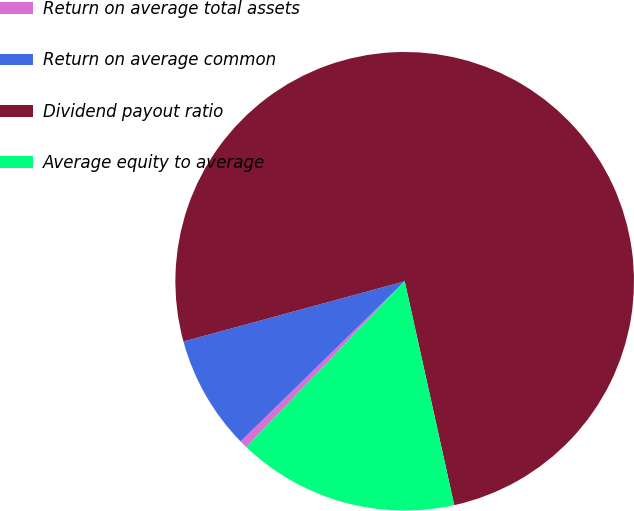Convert chart. <chart><loc_0><loc_0><loc_500><loc_500><pie_chart><fcel>Return on average total assets<fcel>Return on average common<fcel>Dividend payout ratio<fcel>Average equity to average<nl><fcel>0.56%<fcel>8.08%<fcel>75.76%<fcel>15.6%<nl></chart> 